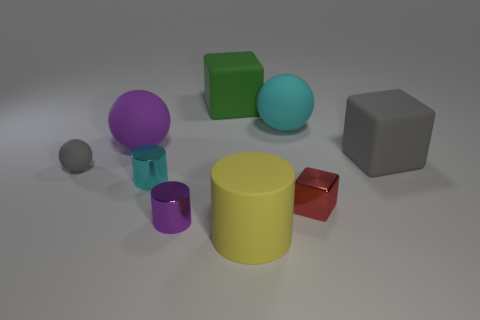Add 1 blue metal objects. How many objects exist? 10 Subtract all big cubes. How many cubes are left? 1 Subtract all cylinders. How many objects are left? 6 Subtract all large green rubber cylinders. Subtract all small red cubes. How many objects are left? 8 Add 5 metallic things. How many metallic things are left? 8 Add 1 rubber blocks. How many rubber blocks exist? 3 Subtract 0 yellow balls. How many objects are left? 9 Subtract 2 balls. How many balls are left? 1 Subtract all blue blocks. Subtract all red cylinders. How many blocks are left? 3 Subtract all red balls. How many gray blocks are left? 1 